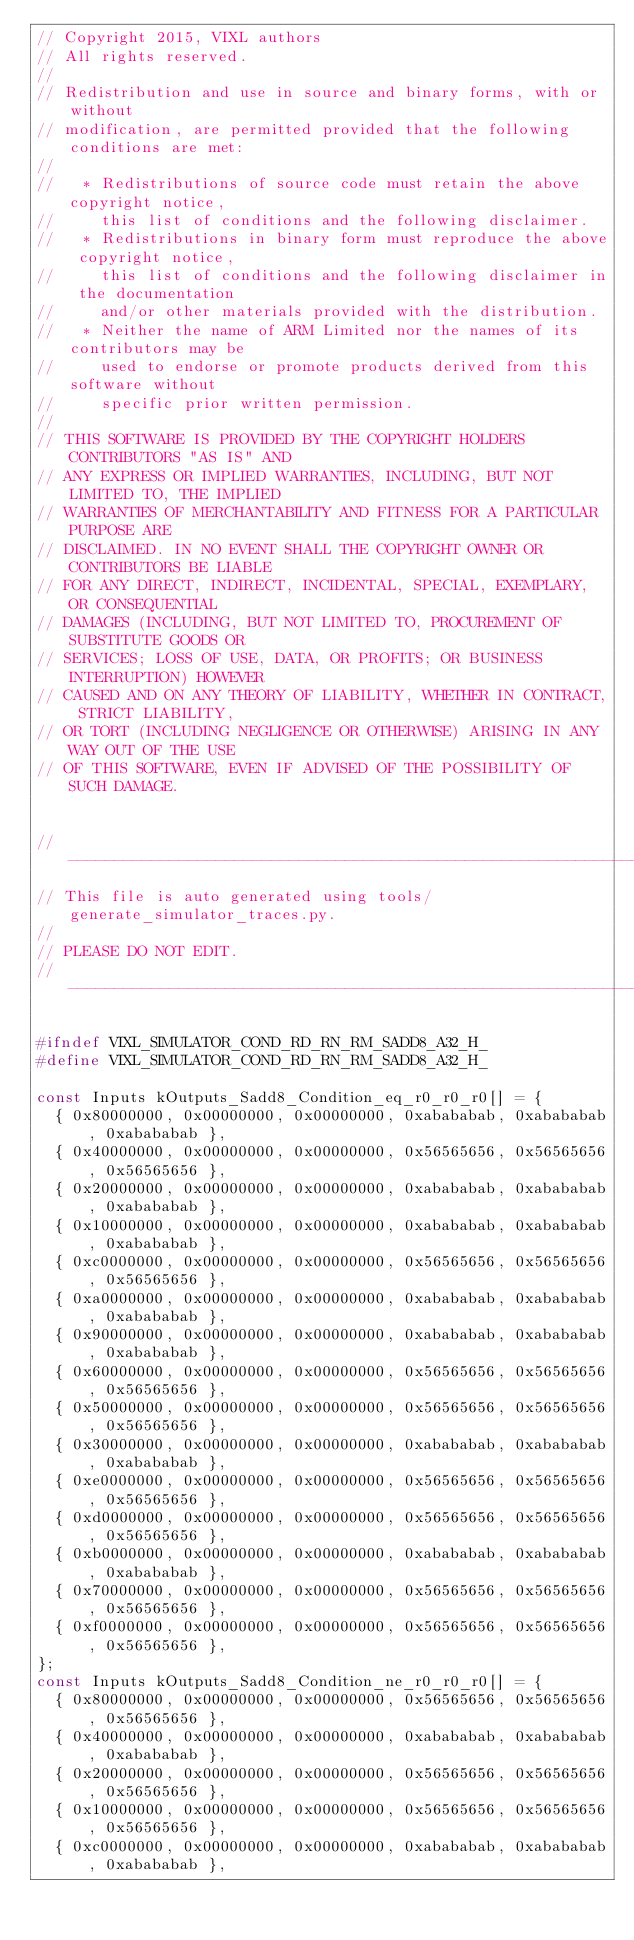Convert code to text. <code><loc_0><loc_0><loc_500><loc_500><_C_>// Copyright 2015, VIXL authors
// All rights reserved.
//
// Redistribution and use in source and binary forms, with or without
// modification, are permitted provided that the following conditions are met:
//
//   * Redistributions of source code must retain the above copyright notice,
//     this list of conditions and the following disclaimer.
//   * Redistributions in binary form must reproduce the above copyright notice,
//     this list of conditions and the following disclaimer in the documentation
//     and/or other materials provided with the distribution.
//   * Neither the name of ARM Limited nor the names of its contributors may be
//     used to endorse or promote products derived from this software without
//     specific prior written permission.
//
// THIS SOFTWARE IS PROVIDED BY THE COPYRIGHT HOLDERS CONTRIBUTORS "AS IS" AND
// ANY EXPRESS OR IMPLIED WARRANTIES, INCLUDING, BUT NOT LIMITED TO, THE IMPLIED
// WARRANTIES OF MERCHANTABILITY AND FITNESS FOR A PARTICULAR PURPOSE ARE
// DISCLAIMED. IN NO EVENT SHALL THE COPYRIGHT OWNER OR CONTRIBUTORS BE LIABLE
// FOR ANY DIRECT, INDIRECT, INCIDENTAL, SPECIAL, EXEMPLARY, OR CONSEQUENTIAL
// DAMAGES (INCLUDING, BUT NOT LIMITED TO, PROCUREMENT OF SUBSTITUTE GOODS OR
// SERVICES; LOSS OF USE, DATA, OR PROFITS; OR BUSINESS INTERRUPTION) HOWEVER
// CAUSED AND ON ANY THEORY OF LIABILITY, WHETHER IN CONTRACT, STRICT LIABILITY,
// OR TORT (INCLUDING NEGLIGENCE OR OTHERWISE) ARISING IN ANY WAY OUT OF THE USE
// OF THIS SOFTWARE, EVEN IF ADVISED OF THE POSSIBILITY OF SUCH DAMAGE.


// ---------------------------------------------------------------------
// This file is auto generated using tools/generate_simulator_traces.py.
//
// PLEASE DO NOT EDIT.
// ---------------------------------------------------------------------

#ifndef VIXL_SIMULATOR_COND_RD_RN_RM_SADD8_A32_H_
#define VIXL_SIMULATOR_COND_RD_RN_RM_SADD8_A32_H_

const Inputs kOutputs_Sadd8_Condition_eq_r0_r0_r0[] = {
  { 0x80000000, 0x00000000, 0x00000000, 0xabababab, 0xabababab, 0xabababab },
  { 0x40000000, 0x00000000, 0x00000000, 0x56565656, 0x56565656, 0x56565656 },
  { 0x20000000, 0x00000000, 0x00000000, 0xabababab, 0xabababab, 0xabababab },
  { 0x10000000, 0x00000000, 0x00000000, 0xabababab, 0xabababab, 0xabababab },
  { 0xc0000000, 0x00000000, 0x00000000, 0x56565656, 0x56565656, 0x56565656 },
  { 0xa0000000, 0x00000000, 0x00000000, 0xabababab, 0xabababab, 0xabababab },
  { 0x90000000, 0x00000000, 0x00000000, 0xabababab, 0xabababab, 0xabababab },
  { 0x60000000, 0x00000000, 0x00000000, 0x56565656, 0x56565656, 0x56565656 },
  { 0x50000000, 0x00000000, 0x00000000, 0x56565656, 0x56565656, 0x56565656 },
  { 0x30000000, 0x00000000, 0x00000000, 0xabababab, 0xabababab, 0xabababab },
  { 0xe0000000, 0x00000000, 0x00000000, 0x56565656, 0x56565656, 0x56565656 },
  { 0xd0000000, 0x00000000, 0x00000000, 0x56565656, 0x56565656, 0x56565656 },
  { 0xb0000000, 0x00000000, 0x00000000, 0xabababab, 0xabababab, 0xabababab },
  { 0x70000000, 0x00000000, 0x00000000, 0x56565656, 0x56565656, 0x56565656 },
  { 0xf0000000, 0x00000000, 0x00000000, 0x56565656, 0x56565656, 0x56565656 },
};
const Inputs kOutputs_Sadd8_Condition_ne_r0_r0_r0[] = {
  { 0x80000000, 0x00000000, 0x00000000, 0x56565656, 0x56565656, 0x56565656 },
  { 0x40000000, 0x00000000, 0x00000000, 0xabababab, 0xabababab, 0xabababab },
  { 0x20000000, 0x00000000, 0x00000000, 0x56565656, 0x56565656, 0x56565656 },
  { 0x10000000, 0x00000000, 0x00000000, 0x56565656, 0x56565656, 0x56565656 },
  { 0xc0000000, 0x00000000, 0x00000000, 0xabababab, 0xabababab, 0xabababab },</code> 